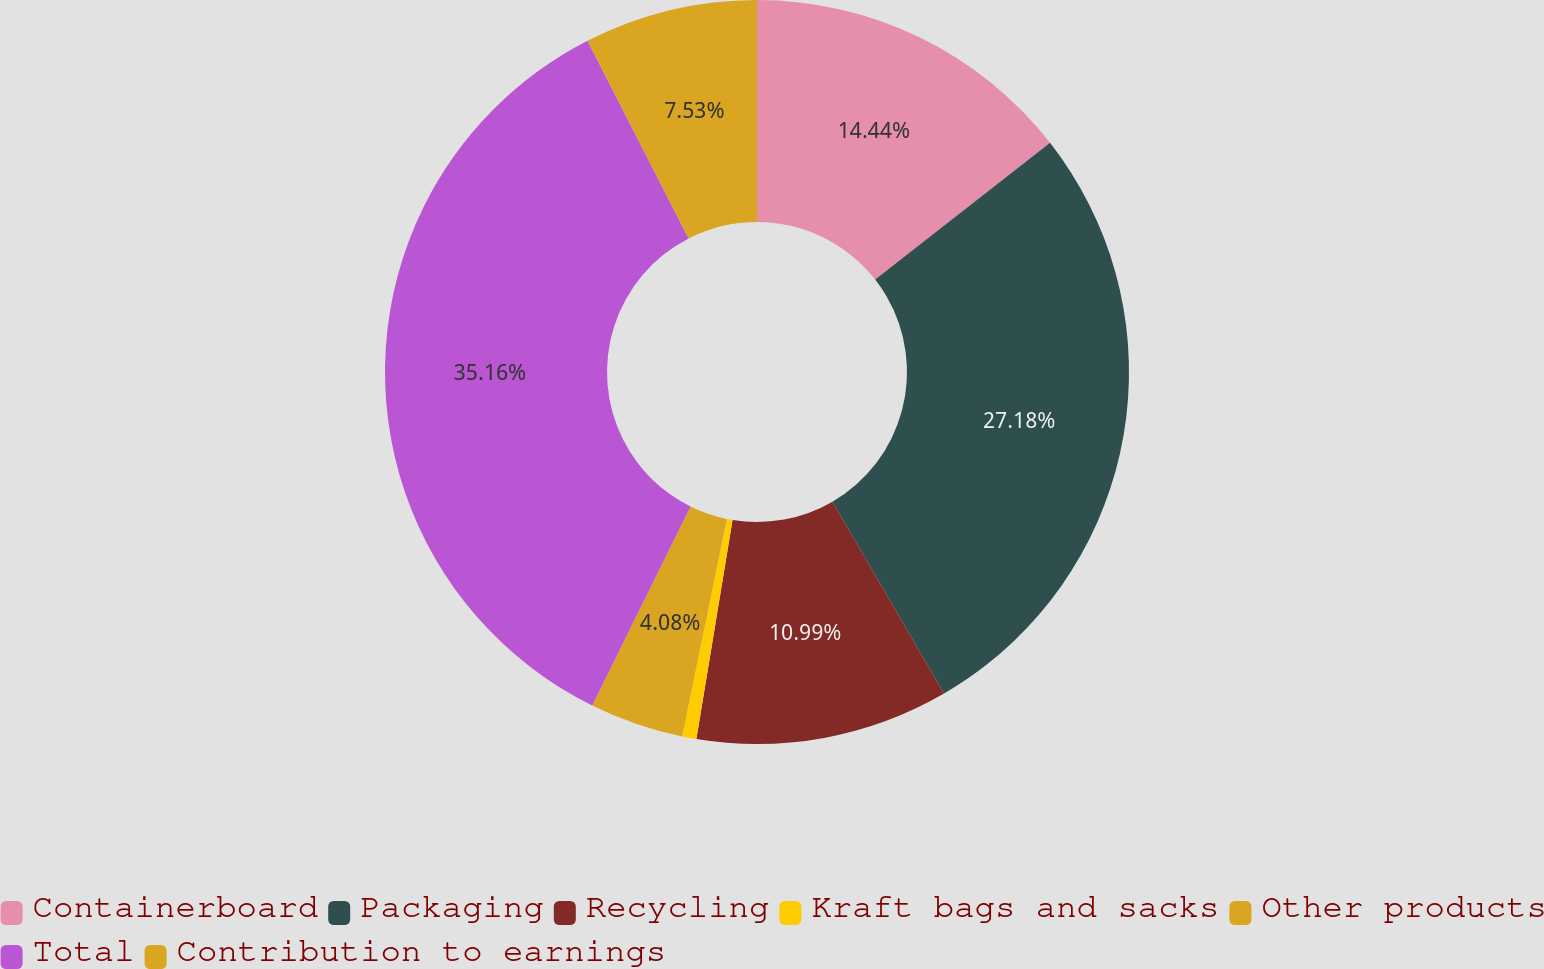Convert chart to OTSL. <chart><loc_0><loc_0><loc_500><loc_500><pie_chart><fcel>Containerboard<fcel>Packaging<fcel>Recycling<fcel>Kraft bags and sacks<fcel>Other products<fcel>Total<fcel>Contribution to earnings<nl><fcel>14.44%<fcel>27.18%<fcel>10.99%<fcel>0.62%<fcel>4.08%<fcel>35.17%<fcel>7.53%<nl></chart> 